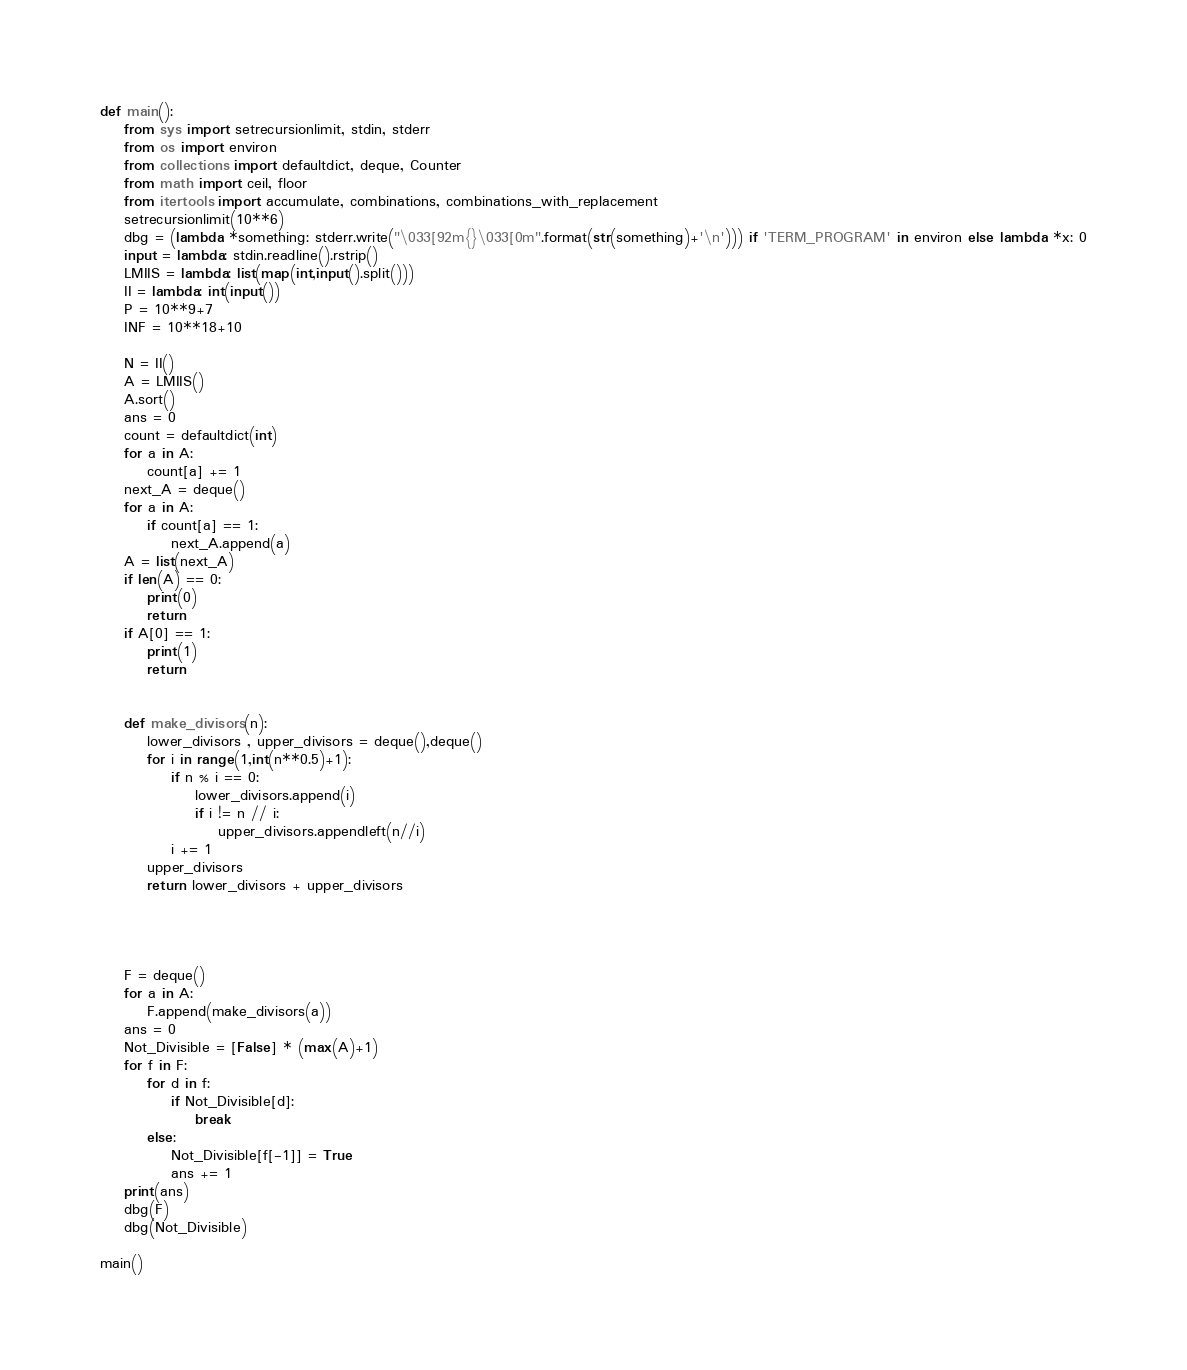<code> <loc_0><loc_0><loc_500><loc_500><_Python_>def main():
    from sys import setrecursionlimit, stdin, stderr
    from os import environ
    from collections import defaultdict, deque, Counter
    from math import ceil, floor
    from itertools import accumulate, combinations, combinations_with_replacement
    setrecursionlimit(10**6)
    dbg = (lambda *something: stderr.write("\033[92m{}\033[0m".format(str(something)+'\n'))) if 'TERM_PROGRAM' in environ else lambda *x: 0
    input = lambda: stdin.readline().rstrip()
    LMIIS = lambda: list(map(int,input().split()))
    II = lambda: int(input())
    P = 10**9+7
    INF = 10**18+10

    N = II()
    A = LMIIS()
    A.sort()
    ans = 0
    count = defaultdict(int)
    for a in A:
        count[a] += 1
    next_A = deque()
    for a in A:
        if count[a] == 1:
            next_A.append(a)
    A = list(next_A)
    if len(A) == 0:
        print(0)
        return
    if A[0] == 1:
        print(1)
        return


    def make_divisors(n):
        lower_divisors , upper_divisors = deque(),deque()
        for i in range(1,int(n**0.5)+1):
            if n % i == 0:
                lower_divisors.append(i)
                if i != n // i:
                    upper_divisors.appendleft(n//i)
            i += 1
        upper_divisors
        return lower_divisors + upper_divisors




    F = deque()
    for a in A:
        F.append(make_divisors(a))
    ans = 0
    Not_Divisible = [False] * (max(A)+1)
    for f in F:
        for d in f:
            if Not_Divisible[d]:
                break
        else:
            Not_Divisible[f[-1]] = True
            ans += 1
    print(ans)
    dbg(F)
    dbg(Not_Divisible)
    
main()</code> 